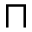<formula> <loc_0><loc_0><loc_500><loc_500>\sqcap</formula> 